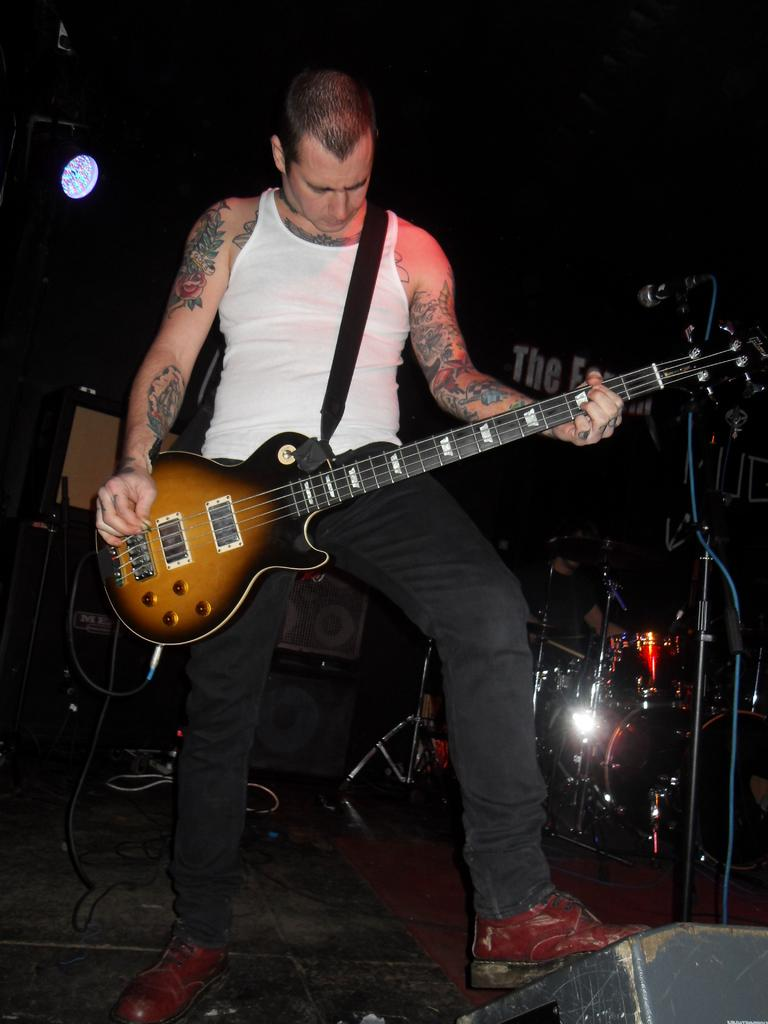What is the main subject of the image? The main subject of the image is a man. What is the man doing in the image? The man is standing and playing a guitar. What else can be seen in the image besides the man? There are musical instruments in the background of the image and a light visible. Can you tell me how many turkeys are visible in the image? There are no turkeys present in the image. What type of coast can be seen in the background of the image? There is no coast visible in the image; it features a man playing a guitar and musical instruments in the background. 